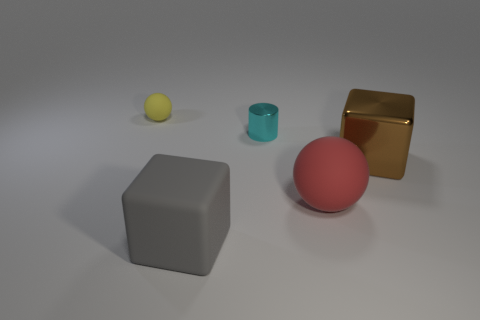Add 1 large gray rubber cubes. How many objects exist? 6 Subtract all brown blocks. How many blocks are left? 1 Subtract all balls. How many objects are left? 3 Add 2 gray matte objects. How many gray matte objects exist? 3 Subtract 0 brown spheres. How many objects are left? 5 Subtract 1 spheres. How many spheres are left? 1 Subtract all yellow cylinders. Subtract all brown spheres. How many cylinders are left? 1 Subtract all small green shiny cylinders. Subtract all big metal blocks. How many objects are left? 4 Add 2 brown things. How many brown things are left? 3 